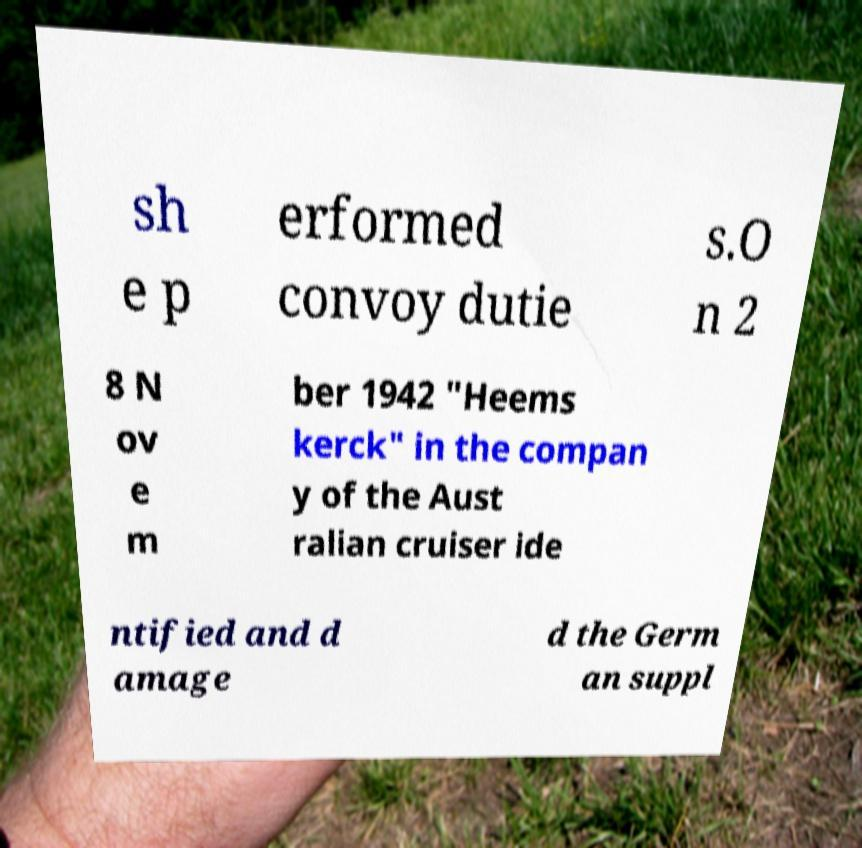Please read and relay the text visible in this image. What does it say? sh e p erformed convoy dutie s.O n 2 8 N ov e m ber 1942 "Heems kerck" in the compan y of the Aust ralian cruiser ide ntified and d amage d the Germ an suppl 